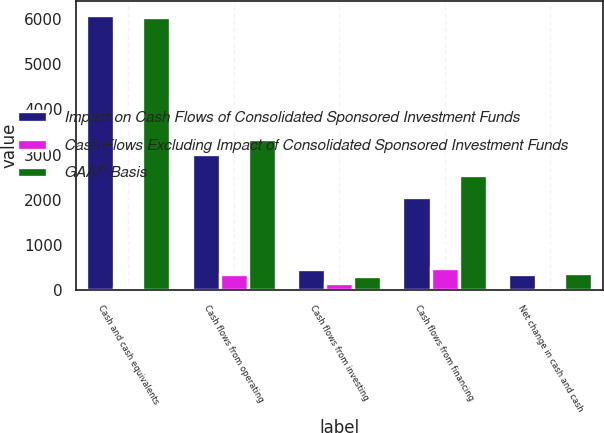Convert chart to OTSL. <chart><loc_0><loc_0><loc_500><loc_500><stacked_bar_chart><ecel><fcel>Cash and cash equivalents<fcel>Cash flows from operating<fcel>Cash flows from investing<fcel>Cash flows from financing<fcel>Net change in cash and cash<nl><fcel>Impact on Cash Flows of Consolidated Sponsored Investment Funds<fcel>6091<fcel>3004<fcel>465<fcel>2064<fcel>360<nl><fcel>Cash Flows Excluding Impact of Consolidated Sponsored Investment Funds<fcel>53<fcel>348<fcel>156<fcel>484<fcel>20<nl><fcel>GAAP Basis<fcel>6038<fcel>3352<fcel>309<fcel>2548<fcel>380<nl></chart> 